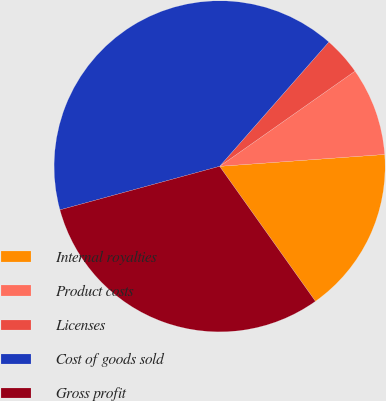Convert chart. <chart><loc_0><loc_0><loc_500><loc_500><pie_chart><fcel>Internal royalties<fcel>Product costs<fcel>Licenses<fcel>Cost of goods sold<fcel>Gross profit<nl><fcel>16.32%<fcel>8.61%<fcel>3.78%<fcel>40.71%<fcel>30.59%<nl></chart> 